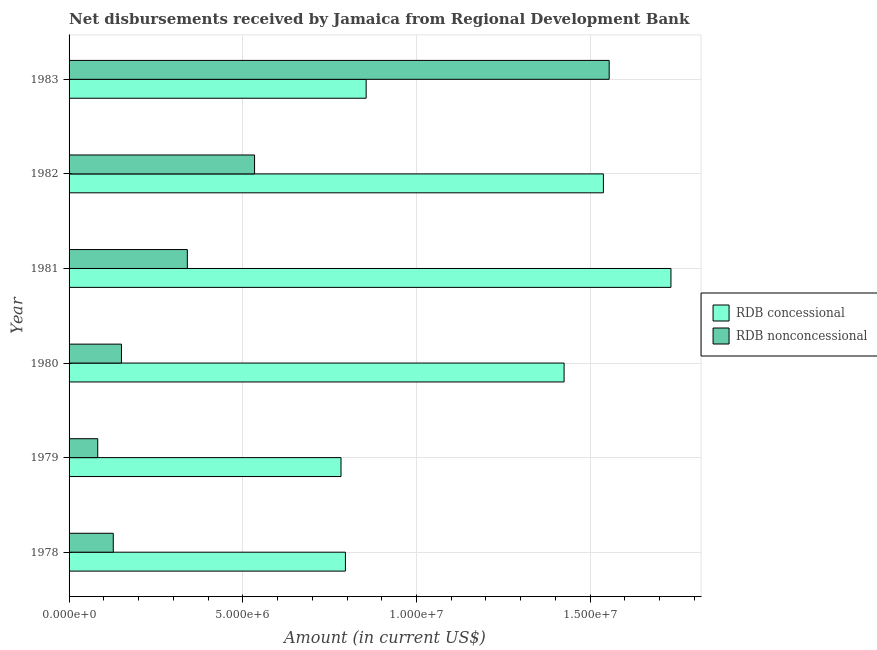How many different coloured bars are there?
Provide a short and direct response. 2. How many bars are there on the 1st tick from the bottom?
Ensure brevity in your answer.  2. What is the net non concessional disbursements from rdb in 1978?
Make the answer very short. 1.27e+06. Across all years, what is the maximum net non concessional disbursements from rdb?
Give a very brief answer. 1.55e+07. Across all years, what is the minimum net non concessional disbursements from rdb?
Provide a succinct answer. 8.25e+05. In which year was the net concessional disbursements from rdb minimum?
Offer a very short reply. 1979. What is the total net non concessional disbursements from rdb in the graph?
Ensure brevity in your answer.  2.79e+07. What is the difference between the net concessional disbursements from rdb in 1979 and that in 1981?
Make the answer very short. -9.50e+06. What is the difference between the net non concessional disbursements from rdb in 1983 and the net concessional disbursements from rdb in 1982?
Make the answer very short. 1.67e+05. What is the average net concessional disbursements from rdb per year?
Make the answer very short. 1.19e+07. In the year 1978, what is the difference between the net non concessional disbursements from rdb and net concessional disbursements from rdb?
Give a very brief answer. -6.68e+06. What is the ratio of the net non concessional disbursements from rdb in 1979 to that in 1983?
Your response must be concise. 0.05. What is the difference between the highest and the second highest net concessional disbursements from rdb?
Your response must be concise. 1.94e+06. What is the difference between the highest and the lowest net non concessional disbursements from rdb?
Make the answer very short. 1.47e+07. Is the sum of the net concessional disbursements from rdb in 1982 and 1983 greater than the maximum net non concessional disbursements from rdb across all years?
Offer a very short reply. Yes. What does the 2nd bar from the top in 1979 represents?
Provide a succinct answer. RDB concessional. What does the 2nd bar from the bottom in 1981 represents?
Your answer should be very brief. RDB nonconcessional. How many years are there in the graph?
Offer a very short reply. 6. What is the difference between two consecutive major ticks on the X-axis?
Your answer should be compact. 5.00e+06. Are the values on the major ticks of X-axis written in scientific E-notation?
Ensure brevity in your answer.  Yes. Does the graph contain any zero values?
Your answer should be compact. No. Does the graph contain grids?
Offer a terse response. Yes. Where does the legend appear in the graph?
Your answer should be very brief. Center right. How many legend labels are there?
Provide a short and direct response. 2. How are the legend labels stacked?
Your answer should be very brief. Vertical. What is the title of the graph?
Your response must be concise. Net disbursements received by Jamaica from Regional Development Bank. What is the label or title of the X-axis?
Give a very brief answer. Amount (in current US$). What is the label or title of the Y-axis?
Offer a very short reply. Year. What is the Amount (in current US$) in RDB concessional in 1978?
Your answer should be very brief. 7.95e+06. What is the Amount (in current US$) in RDB nonconcessional in 1978?
Your response must be concise. 1.27e+06. What is the Amount (in current US$) of RDB concessional in 1979?
Offer a very short reply. 7.83e+06. What is the Amount (in current US$) in RDB nonconcessional in 1979?
Provide a short and direct response. 8.25e+05. What is the Amount (in current US$) of RDB concessional in 1980?
Your response must be concise. 1.42e+07. What is the Amount (in current US$) in RDB nonconcessional in 1980?
Your answer should be compact. 1.51e+06. What is the Amount (in current US$) of RDB concessional in 1981?
Offer a very short reply. 1.73e+07. What is the Amount (in current US$) of RDB nonconcessional in 1981?
Give a very brief answer. 3.40e+06. What is the Amount (in current US$) in RDB concessional in 1982?
Keep it short and to the point. 1.54e+07. What is the Amount (in current US$) in RDB nonconcessional in 1982?
Your answer should be very brief. 5.34e+06. What is the Amount (in current US$) in RDB concessional in 1983?
Give a very brief answer. 8.55e+06. What is the Amount (in current US$) of RDB nonconcessional in 1983?
Keep it short and to the point. 1.55e+07. Across all years, what is the maximum Amount (in current US$) of RDB concessional?
Your response must be concise. 1.73e+07. Across all years, what is the maximum Amount (in current US$) of RDB nonconcessional?
Give a very brief answer. 1.55e+07. Across all years, what is the minimum Amount (in current US$) in RDB concessional?
Your answer should be very brief. 7.83e+06. Across all years, what is the minimum Amount (in current US$) of RDB nonconcessional?
Keep it short and to the point. 8.25e+05. What is the total Amount (in current US$) in RDB concessional in the graph?
Your response must be concise. 7.13e+07. What is the total Amount (in current US$) in RDB nonconcessional in the graph?
Give a very brief answer. 2.79e+07. What is the difference between the Amount (in current US$) of RDB concessional in 1978 and that in 1979?
Offer a very short reply. 1.27e+05. What is the difference between the Amount (in current US$) of RDB nonconcessional in 1978 and that in 1979?
Keep it short and to the point. 4.47e+05. What is the difference between the Amount (in current US$) of RDB concessional in 1978 and that in 1980?
Provide a short and direct response. -6.29e+06. What is the difference between the Amount (in current US$) in RDB nonconcessional in 1978 and that in 1980?
Provide a succinct answer. -2.36e+05. What is the difference between the Amount (in current US$) of RDB concessional in 1978 and that in 1981?
Provide a succinct answer. -9.37e+06. What is the difference between the Amount (in current US$) in RDB nonconcessional in 1978 and that in 1981?
Give a very brief answer. -2.13e+06. What is the difference between the Amount (in current US$) of RDB concessional in 1978 and that in 1982?
Ensure brevity in your answer.  -7.42e+06. What is the difference between the Amount (in current US$) in RDB nonconcessional in 1978 and that in 1982?
Make the answer very short. -4.07e+06. What is the difference between the Amount (in current US$) of RDB concessional in 1978 and that in 1983?
Offer a very short reply. -5.97e+05. What is the difference between the Amount (in current US$) in RDB nonconcessional in 1978 and that in 1983?
Provide a succinct answer. -1.43e+07. What is the difference between the Amount (in current US$) in RDB concessional in 1979 and that in 1980?
Your answer should be compact. -6.42e+06. What is the difference between the Amount (in current US$) in RDB nonconcessional in 1979 and that in 1980?
Provide a succinct answer. -6.83e+05. What is the difference between the Amount (in current US$) of RDB concessional in 1979 and that in 1981?
Make the answer very short. -9.50e+06. What is the difference between the Amount (in current US$) of RDB nonconcessional in 1979 and that in 1981?
Offer a terse response. -2.58e+06. What is the difference between the Amount (in current US$) of RDB concessional in 1979 and that in 1982?
Your answer should be compact. -7.55e+06. What is the difference between the Amount (in current US$) of RDB nonconcessional in 1979 and that in 1982?
Provide a succinct answer. -4.51e+06. What is the difference between the Amount (in current US$) of RDB concessional in 1979 and that in 1983?
Make the answer very short. -7.24e+05. What is the difference between the Amount (in current US$) in RDB nonconcessional in 1979 and that in 1983?
Your response must be concise. -1.47e+07. What is the difference between the Amount (in current US$) in RDB concessional in 1980 and that in 1981?
Provide a succinct answer. -3.08e+06. What is the difference between the Amount (in current US$) of RDB nonconcessional in 1980 and that in 1981?
Your response must be concise. -1.90e+06. What is the difference between the Amount (in current US$) in RDB concessional in 1980 and that in 1982?
Make the answer very short. -1.13e+06. What is the difference between the Amount (in current US$) of RDB nonconcessional in 1980 and that in 1982?
Ensure brevity in your answer.  -3.83e+06. What is the difference between the Amount (in current US$) in RDB concessional in 1980 and that in 1983?
Offer a terse response. 5.70e+06. What is the difference between the Amount (in current US$) in RDB nonconcessional in 1980 and that in 1983?
Offer a very short reply. -1.40e+07. What is the difference between the Amount (in current US$) of RDB concessional in 1981 and that in 1982?
Make the answer very short. 1.94e+06. What is the difference between the Amount (in current US$) of RDB nonconcessional in 1981 and that in 1982?
Provide a succinct answer. -1.94e+06. What is the difference between the Amount (in current US$) of RDB concessional in 1981 and that in 1983?
Ensure brevity in your answer.  8.77e+06. What is the difference between the Amount (in current US$) of RDB nonconcessional in 1981 and that in 1983?
Ensure brevity in your answer.  -1.21e+07. What is the difference between the Amount (in current US$) in RDB concessional in 1982 and that in 1983?
Your answer should be very brief. 6.83e+06. What is the difference between the Amount (in current US$) of RDB nonconcessional in 1982 and that in 1983?
Offer a very short reply. -1.02e+07. What is the difference between the Amount (in current US$) of RDB concessional in 1978 and the Amount (in current US$) of RDB nonconcessional in 1979?
Give a very brief answer. 7.13e+06. What is the difference between the Amount (in current US$) of RDB concessional in 1978 and the Amount (in current US$) of RDB nonconcessional in 1980?
Offer a very short reply. 6.45e+06. What is the difference between the Amount (in current US$) of RDB concessional in 1978 and the Amount (in current US$) of RDB nonconcessional in 1981?
Ensure brevity in your answer.  4.55e+06. What is the difference between the Amount (in current US$) in RDB concessional in 1978 and the Amount (in current US$) in RDB nonconcessional in 1982?
Your answer should be compact. 2.62e+06. What is the difference between the Amount (in current US$) of RDB concessional in 1978 and the Amount (in current US$) of RDB nonconcessional in 1983?
Your answer should be very brief. -7.59e+06. What is the difference between the Amount (in current US$) in RDB concessional in 1979 and the Amount (in current US$) in RDB nonconcessional in 1980?
Give a very brief answer. 6.32e+06. What is the difference between the Amount (in current US$) in RDB concessional in 1979 and the Amount (in current US$) in RDB nonconcessional in 1981?
Make the answer very short. 4.42e+06. What is the difference between the Amount (in current US$) in RDB concessional in 1979 and the Amount (in current US$) in RDB nonconcessional in 1982?
Ensure brevity in your answer.  2.49e+06. What is the difference between the Amount (in current US$) of RDB concessional in 1979 and the Amount (in current US$) of RDB nonconcessional in 1983?
Provide a succinct answer. -7.72e+06. What is the difference between the Amount (in current US$) of RDB concessional in 1980 and the Amount (in current US$) of RDB nonconcessional in 1981?
Ensure brevity in your answer.  1.08e+07. What is the difference between the Amount (in current US$) in RDB concessional in 1980 and the Amount (in current US$) in RDB nonconcessional in 1982?
Offer a terse response. 8.91e+06. What is the difference between the Amount (in current US$) of RDB concessional in 1980 and the Amount (in current US$) of RDB nonconcessional in 1983?
Make the answer very short. -1.30e+06. What is the difference between the Amount (in current US$) of RDB concessional in 1981 and the Amount (in current US$) of RDB nonconcessional in 1982?
Offer a terse response. 1.20e+07. What is the difference between the Amount (in current US$) of RDB concessional in 1981 and the Amount (in current US$) of RDB nonconcessional in 1983?
Provide a succinct answer. 1.78e+06. What is the difference between the Amount (in current US$) in RDB concessional in 1982 and the Amount (in current US$) in RDB nonconcessional in 1983?
Your answer should be very brief. -1.67e+05. What is the average Amount (in current US$) in RDB concessional per year?
Keep it short and to the point. 1.19e+07. What is the average Amount (in current US$) in RDB nonconcessional per year?
Keep it short and to the point. 4.65e+06. In the year 1978, what is the difference between the Amount (in current US$) in RDB concessional and Amount (in current US$) in RDB nonconcessional?
Your answer should be very brief. 6.68e+06. In the year 1979, what is the difference between the Amount (in current US$) of RDB concessional and Amount (in current US$) of RDB nonconcessional?
Offer a terse response. 7.00e+06. In the year 1980, what is the difference between the Amount (in current US$) in RDB concessional and Amount (in current US$) in RDB nonconcessional?
Provide a short and direct response. 1.27e+07. In the year 1981, what is the difference between the Amount (in current US$) in RDB concessional and Amount (in current US$) in RDB nonconcessional?
Keep it short and to the point. 1.39e+07. In the year 1982, what is the difference between the Amount (in current US$) of RDB concessional and Amount (in current US$) of RDB nonconcessional?
Your response must be concise. 1.00e+07. In the year 1983, what is the difference between the Amount (in current US$) in RDB concessional and Amount (in current US$) in RDB nonconcessional?
Make the answer very short. -7.00e+06. What is the ratio of the Amount (in current US$) of RDB concessional in 1978 to that in 1979?
Provide a succinct answer. 1.02. What is the ratio of the Amount (in current US$) of RDB nonconcessional in 1978 to that in 1979?
Offer a terse response. 1.54. What is the ratio of the Amount (in current US$) of RDB concessional in 1978 to that in 1980?
Your answer should be very brief. 0.56. What is the ratio of the Amount (in current US$) of RDB nonconcessional in 1978 to that in 1980?
Offer a terse response. 0.84. What is the ratio of the Amount (in current US$) of RDB concessional in 1978 to that in 1981?
Make the answer very short. 0.46. What is the ratio of the Amount (in current US$) in RDB nonconcessional in 1978 to that in 1981?
Your response must be concise. 0.37. What is the ratio of the Amount (in current US$) in RDB concessional in 1978 to that in 1982?
Provide a short and direct response. 0.52. What is the ratio of the Amount (in current US$) of RDB nonconcessional in 1978 to that in 1982?
Offer a terse response. 0.24. What is the ratio of the Amount (in current US$) of RDB concessional in 1978 to that in 1983?
Make the answer very short. 0.93. What is the ratio of the Amount (in current US$) of RDB nonconcessional in 1978 to that in 1983?
Provide a succinct answer. 0.08. What is the ratio of the Amount (in current US$) in RDB concessional in 1979 to that in 1980?
Offer a terse response. 0.55. What is the ratio of the Amount (in current US$) of RDB nonconcessional in 1979 to that in 1980?
Offer a very short reply. 0.55. What is the ratio of the Amount (in current US$) of RDB concessional in 1979 to that in 1981?
Offer a terse response. 0.45. What is the ratio of the Amount (in current US$) in RDB nonconcessional in 1979 to that in 1981?
Make the answer very short. 0.24. What is the ratio of the Amount (in current US$) of RDB concessional in 1979 to that in 1982?
Ensure brevity in your answer.  0.51. What is the ratio of the Amount (in current US$) in RDB nonconcessional in 1979 to that in 1982?
Make the answer very short. 0.15. What is the ratio of the Amount (in current US$) in RDB concessional in 1979 to that in 1983?
Ensure brevity in your answer.  0.92. What is the ratio of the Amount (in current US$) of RDB nonconcessional in 1979 to that in 1983?
Ensure brevity in your answer.  0.05. What is the ratio of the Amount (in current US$) of RDB concessional in 1980 to that in 1981?
Provide a succinct answer. 0.82. What is the ratio of the Amount (in current US$) of RDB nonconcessional in 1980 to that in 1981?
Offer a terse response. 0.44. What is the ratio of the Amount (in current US$) of RDB concessional in 1980 to that in 1982?
Your response must be concise. 0.93. What is the ratio of the Amount (in current US$) of RDB nonconcessional in 1980 to that in 1982?
Give a very brief answer. 0.28. What is the ratio of the Amount (in current US$) of RDB concessional in 1980 to that in 1983?
Give a very brief answer. 1.67. What is the ratio of the Amount (in current US$) of RDB nonconcessional in 1980 to that in 1983?
Your response must be concise. 0.1. What is the ratio of the Amount (in current US$) of RDB concessional in 1981 to that in 1982?
Your answer should be very brief. 1.13. What is the ratio of the Amount (in current US$) of RDB nonconcessional in 1981 to that in 1982?
Offer a very short reply. 0.64. What is the ratio of the Amount (in current US$) in RDB concessional in 1981 to that in 1983?
Give a very brief answer. 2.03. What is the ratio of the Amount (in current US$) of RDB nonconcessional in 1981 to that in 1983?
Keep it short and to the point. 0.22. What is the ratio of the Amount (in current US$) of RDB concessional in 1982 to that in 1983?
Provide a short and direct response. 1.8. What is the ratio of the Amount (in current US$) in RDB nonconcessional in 1982 to that in 1983?
Provide a succinct answer. 0.34. What is the difference between the highest and the second highest Amount (in current US$) in RDB concessional?
Offer a terse response. 1.94e+06. What is the difference between the highest and the second highest Amount (in current US$) of RDB nonconcessional?
Give a very brief answer. 1.02e+07. What is the difference between the highest and the lowest Amount (in current US$) of RDB concessional?
Provide a short and direct response. 9.50e+06. What is the difference between the highest and the lowest Amount (in current US$) in RDB nonconcessional?
Offer a very short reply. 1.47e+07. 